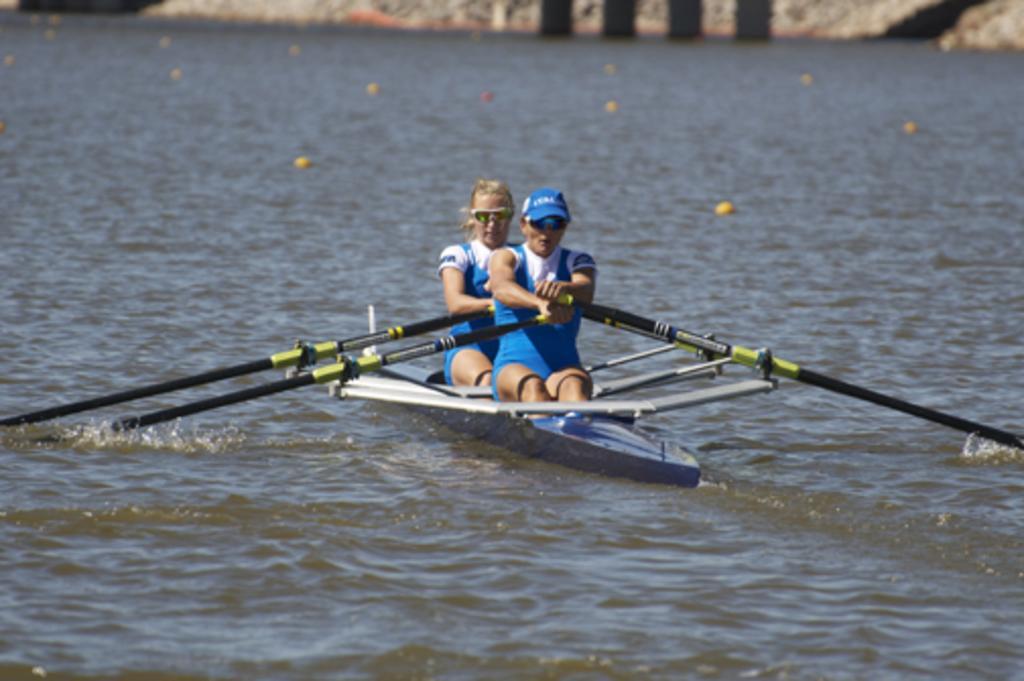Please provide a concise description of this image. In the image we can see two people wearing the same costume, goggles and one is wearing a cap. They are sitting in the boat and they are holding paddles, and the boat is in the water. 